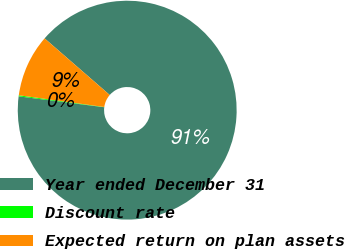Convert chart to OTSL. <chart><loc_0><loc_0><loc_500><loc_500><pie_chart><fcel>Year ended December 31<fcel>Discount rate<fcel>Expected return on plan assets<nl><fcel>90.64%<fcel>0.16%<fcel>9.21%<nl></chart> 